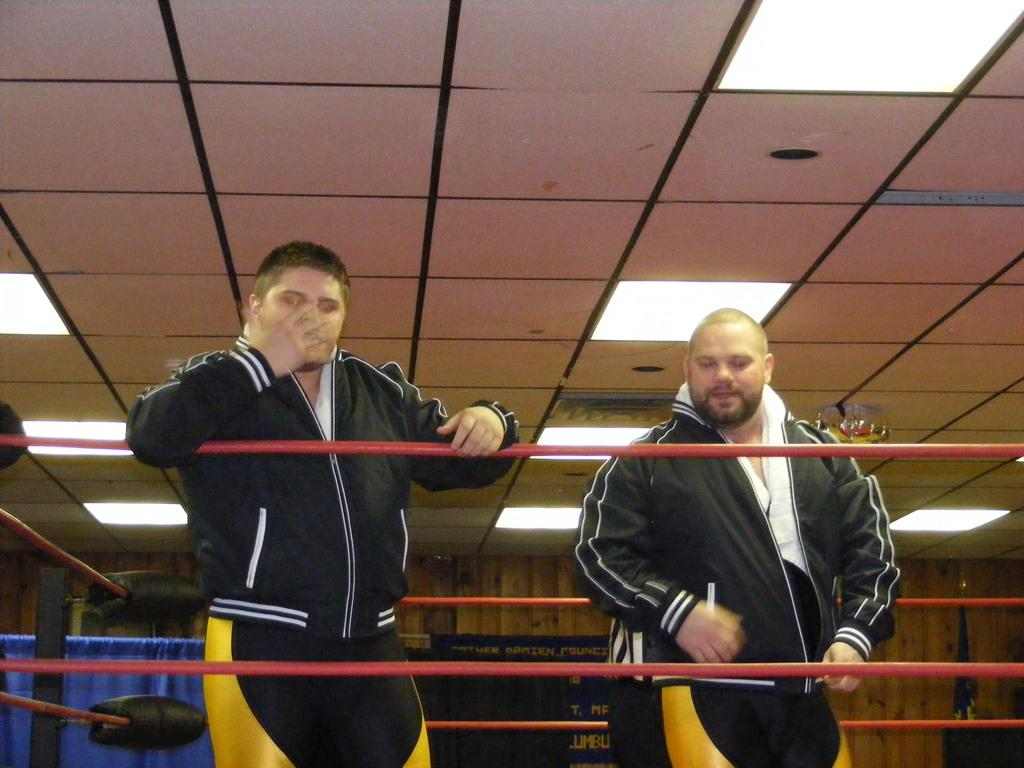How many people are in the image? There are two men in the image. What are the men doing in the image? The men are standing inside a wrestling ring. What can be seen in the ceiling of the wrestling ring? There are lights in the ceiling of the wrestling ring. Where is the bead located in the image? There is no bead present in the image. How many people are in the cellar in the image? There is no cellar present in the image; the men are standing inside a wrestling ring. 